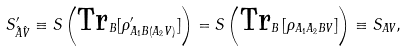<formula> <loc_0><loc_0><loc_500><loc_500>S _ { \hat { A } \hat { V } } ^ { \prime } \equiv S \left ( \text {Tr} _ { B } [ \rho _ { A _ { 1 } B ( A _ { 2 } V ) } ^ { \prime } ] \right ) = S \left ( \text {Tr} _ { B } \left [ \rho _ { A _ { 1 } A _ { 2 } B V } \right ] \right ) \equiv S _ { A V } ,</formula> 